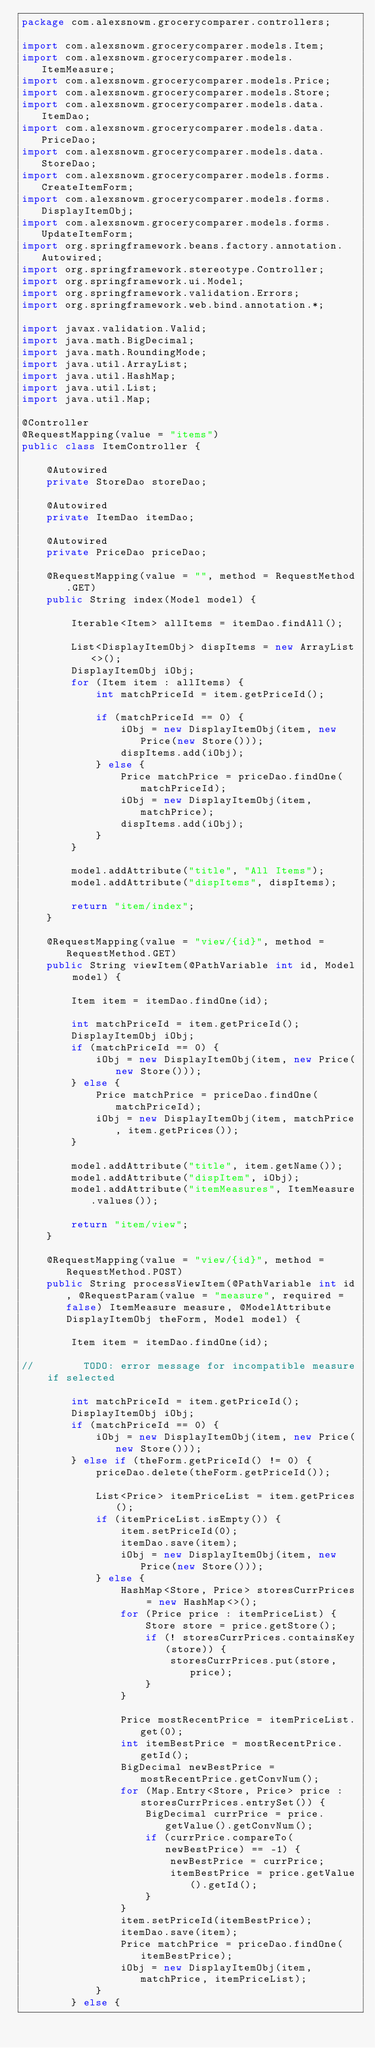Convert code to text. <code><loc_0><loc_0><loc_500><loc_500><_Java_>package com.alexsnowm.grocerycomparer.controllers;

import com.alexsnowm.grocerycomparer.models.Item;
import com.alexsnowm.grocerycomparer.models.ItemMeasure;
import com.alexsnowm.grocerycomparer.models.Price;
import com.alexsnowm.grocerycomparer.models.Store;
import com.alexsnowm.grocerycomparer.models.data.ItemDao;
import com.alexsnowm.grocerycomparer.models.data.PriceDao;
import com.alexsnowm.grocerycomparer.models.data.StoreDao;
import com.alexsnowm.grocerycomparer.models.forms.CreateItemForm;
import com.alexsnowm.grocerycomparer.models.forms.DisplayItemObj;
import com.alexsnowm.grocerycomparer.models.forms.UpdateItemForm;
import org.springframework.beans.factory.annotation.Autowired;
import org.springframework.stereotype.Controller;
import org.springframework.ui.Model;
import org.springframework.validation.Errors;
import org.springframework.web.bind.annotation.*;

import javax.validation.Valid;
import java.math.BigDecimal;
import java.math.RoundingMode;
import java.util.ArrayList;
import java.util.HashMap;
import java.util.List;
import java.util.Map;

@Controller
@RequestMapping(value = "items")
public class ItemController {

    @Autowired
    private StoreDao storeDao;

    @Autowired
    private ItemDao itemDao;

    @Autowired
    private PriceDao priceDao;

    @RequestMapping(value = "", method = RequestMethod.GET)
    public String index(Model model) {

        Iterable<Item> allItems = itemDao.findAll();

        List<DisplayItemObj> dispItems = new ArrayList<>();
        DisplayItemObj iObj;
        for (Item item : allItems) {
            int matchPriceId = item.getPriceId();

            if (matchPriceId == 0) {
                iObj = new DisplayItemObj(item, new Price(new Store()));
                dispItems.add(iObj);
            } else {
                Price matchPrice = priceDao.findOne(matchPriceId);
                iObj = new DisplayItemObj(item, matchPrice);
                dispItems.add(iObj);
            }
        }

        model.addAttribute("title", "All Items");
        model.addAttribute("dispItems", dispItems);

        return "item/index";
    }

    @RequestMapping(value = "view/{id}", method = RequestMethod.GET)
    public String viewItem(@PathVariable int id, Model model) {

        Item item = itemDao.findOne(id);

        int matchPriceId = item.getPriceId();
        DisplayItemObj iObj;
        if (matchPriceId == 0) {
            iObj = new DisplayItemObj(item, new Price(new Store()));
        } else {
            Price matchPrice = priceDao.findOne(matchPriceId);
            iObj = new DisplayItemObj(item, matchPrice, item.getPrices());
        }

        model.addAttribute("title", item.getName());
        model.addAttribute("dispItem", iObj);
        model.addAttribute("itemMeasures", ItemMeasure.values());

        return "item/view";
    }

    @RequestMapping(value = "view/{id}", method = RequestMethod.POST)
    public String processViewItem(@PathVariable int id, @RequestParam(value = "measure", required = false) ItemMeasure measure, @ModelAttribute DisplayItemObj theForm, Model model) {

        Item item = itemDao.findOne(id);

//        TODO: error message for incompatible measure if selected

        int matchPriceId = item.getPriceId();
        DisplayItemObj iObj;
        if (matchPriceId == 0) {
            iObj = new DisplayItemObj(item, new Price(new Store()));
        } else if (theForm.getPriceId() != 0) {
            priceDao.delete(theForm.getPriceId());

            List<Price> itemPriceList = item.getPrices();
            if (itemPriceList.isEmpty()) {
                item.setPriceId(0);
                itemDao.save(item);
                iObj = new DisplayItemObj(item, new Price(new Store()));
            } else {
                HashMap<Store, Price> storesCurrPrices = new HashMap<>();
                for (Price price : itemPriceList) {
                    Store store = price.getStore();
                    if (! storesCurrPrices.containsKey(store)) {
                        storesCurrPrices.put(store, price);
                    }
                }

                Price mostRecentPrice = itemPriceList.get(0);
                int itemBestPrice = mostRecentPrice.getId();
                BigDecimal newBestPrice = mostRecentPrice.getConvNum();
                for (Map.Entry<Store, Price> price : storesCurrPrices.entrySet()) {
                    BigDecimal currPrice = price.getValue().getConvNum();
                    if (currPrice.compareTo(newBestPrice) == -1) {
                        newBestPrice = currPrice;
                        itemBestPrice = price.getValue().getId();
                    }
                }
                item.setPriceId(itemBestPrice);
                itemDao.save(item);
                Price matchPrice = priceDao.findOne(itemBestPrice);
                iObj = new DisplayItemObj(item, matchPrice, itemPriceList);
            }
        } else {</code> 